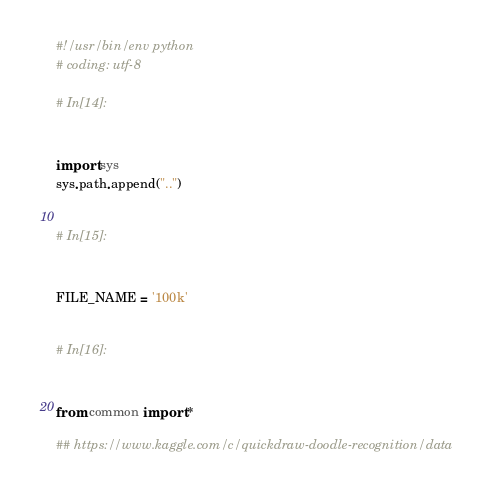Convert code to text. <code><loc_0><loc_0><loc_500><loc_500><_Python_>#!/usr/bin/env python
# coding: utf-8

# In[14]:


import sys
sys.path.append("..")


# In[15]:


FILE_NAME = '100k'


# In[16]:


from common import *

## https://www.kaggle.com/c/quickdraw-doodle-recognition/data</code> 